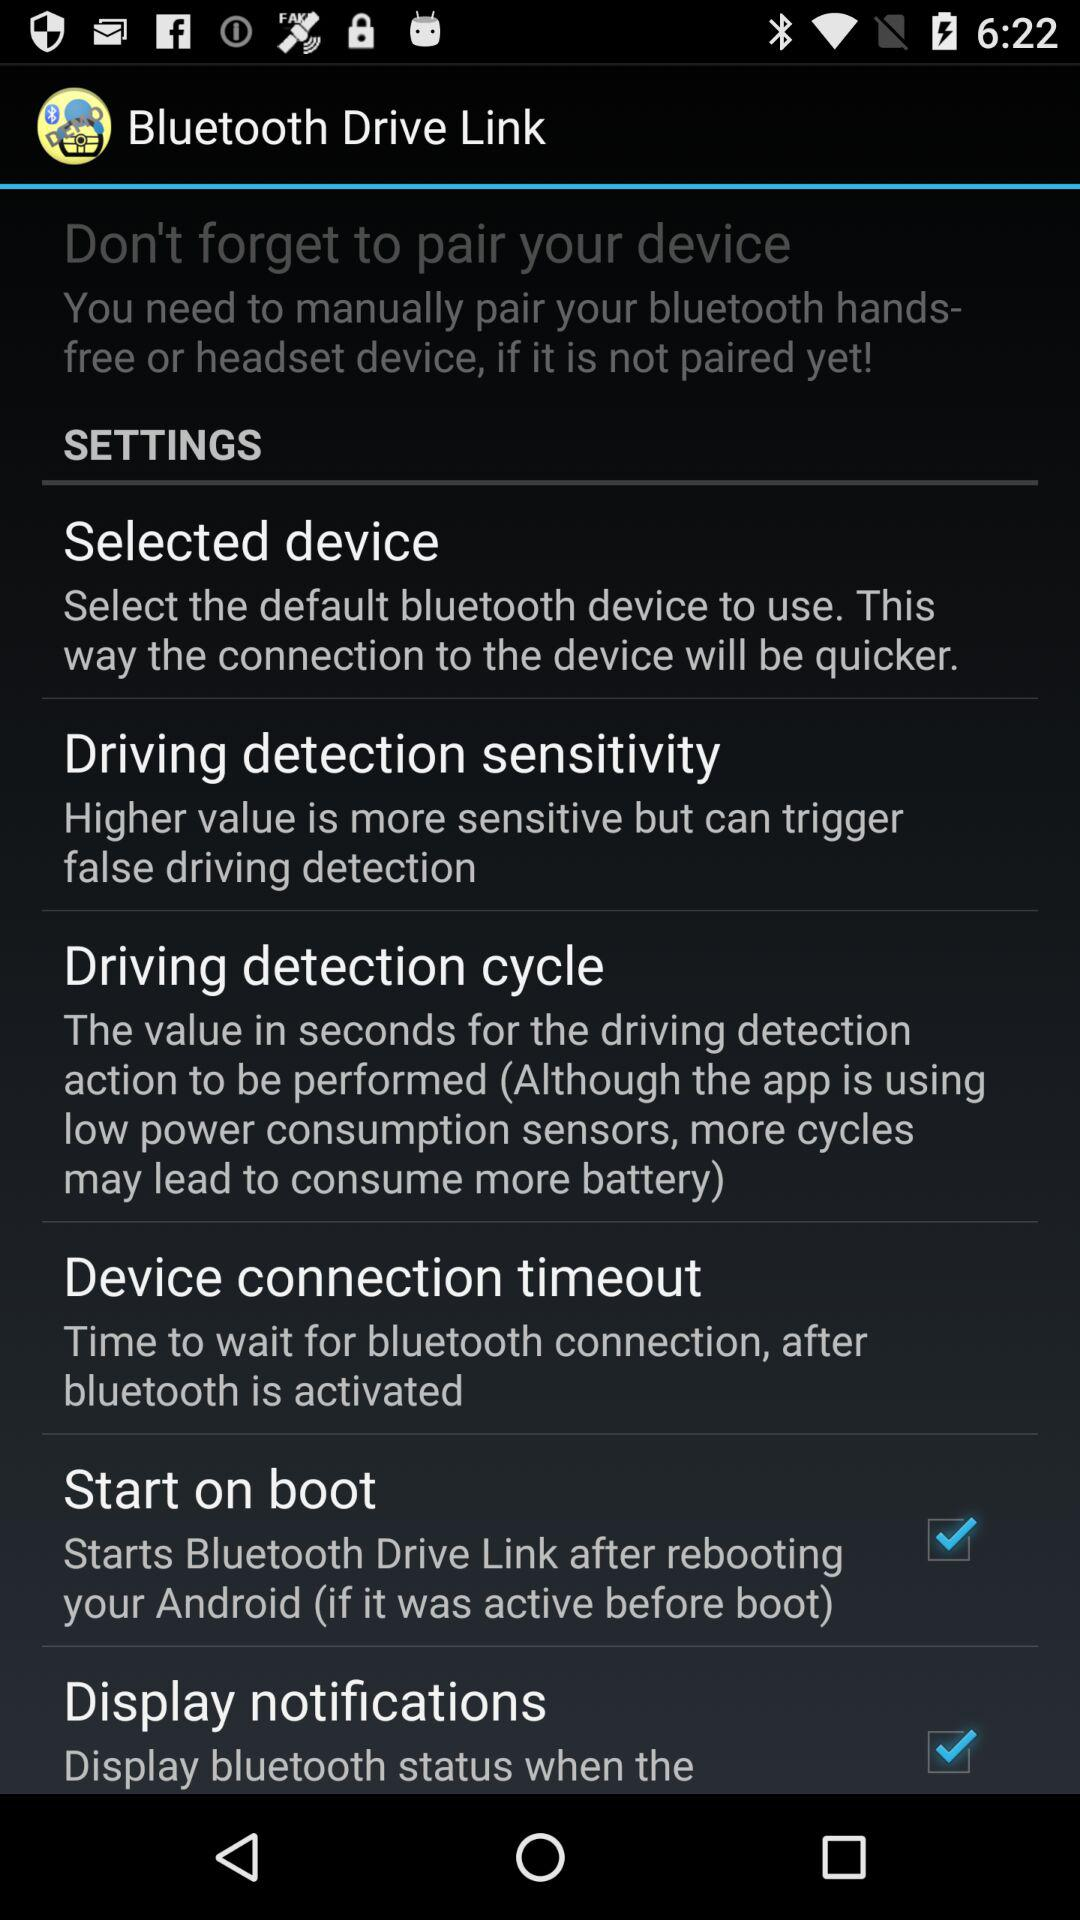What is the status of "Start on boot"? The status is "on". 